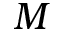Convert formula to latex. <formula><loc_0><loc_0><loc_500><loc_500>M</formula> 